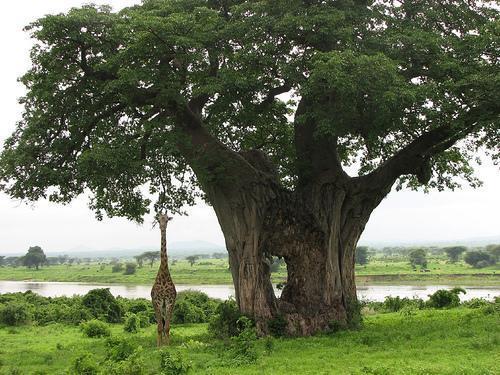How many animals?
Give a very brief answer. 1. How many people are in the picture?
Give a very brief answer. 0. 